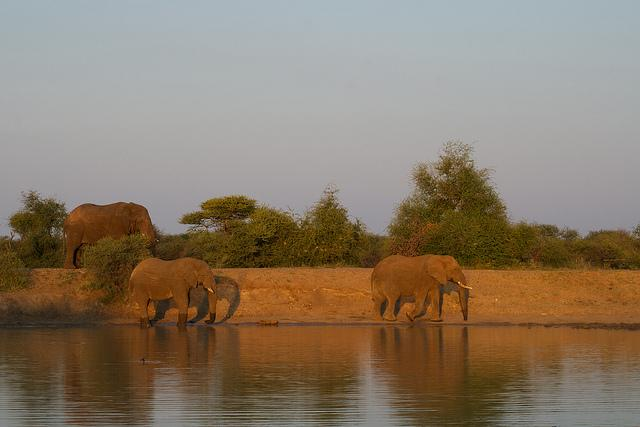What direction are the elephants facing? Please explain your reasoning. right. The elephants are going the opposite direction of left. 